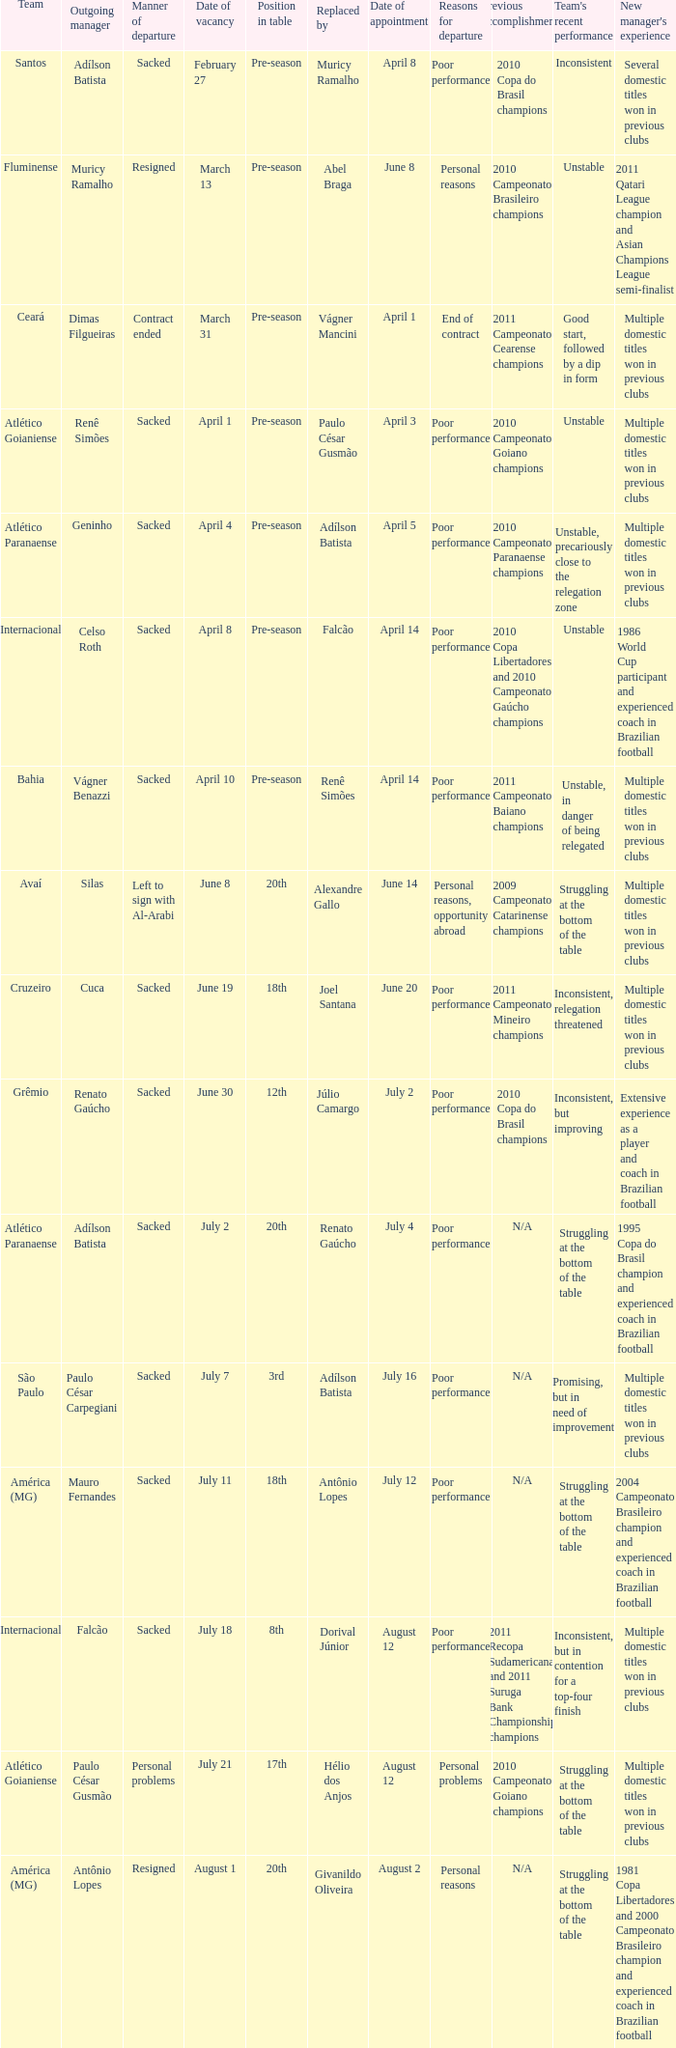Who was the new Santos manager? Muricy Ramalho. 